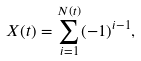<formula> <loc_0><loc_0><loc_500><loc_500>X ( t ) = \sum _ { i = 1 } ^ { N ( t ) } ( - 1 ) ^ { i - 1 } ,</formula> 